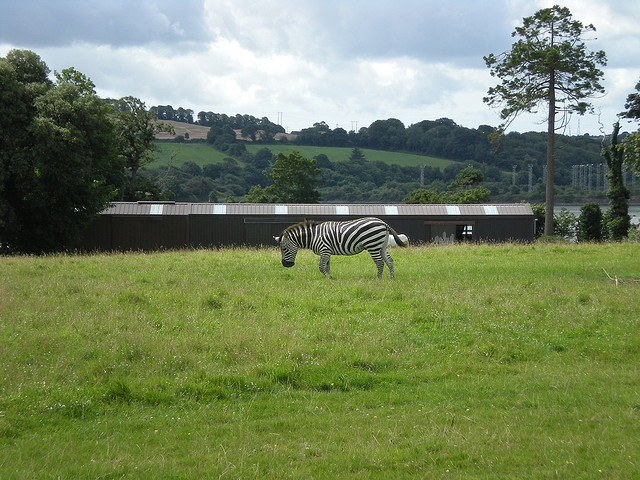Describe the objects in this image and their specific colors. I can see zebra in lightblue, black, gray, darkgray, and ivory tones and zebra in lightblue, black, gray, darkgreen, and darkgray tones in this image. 